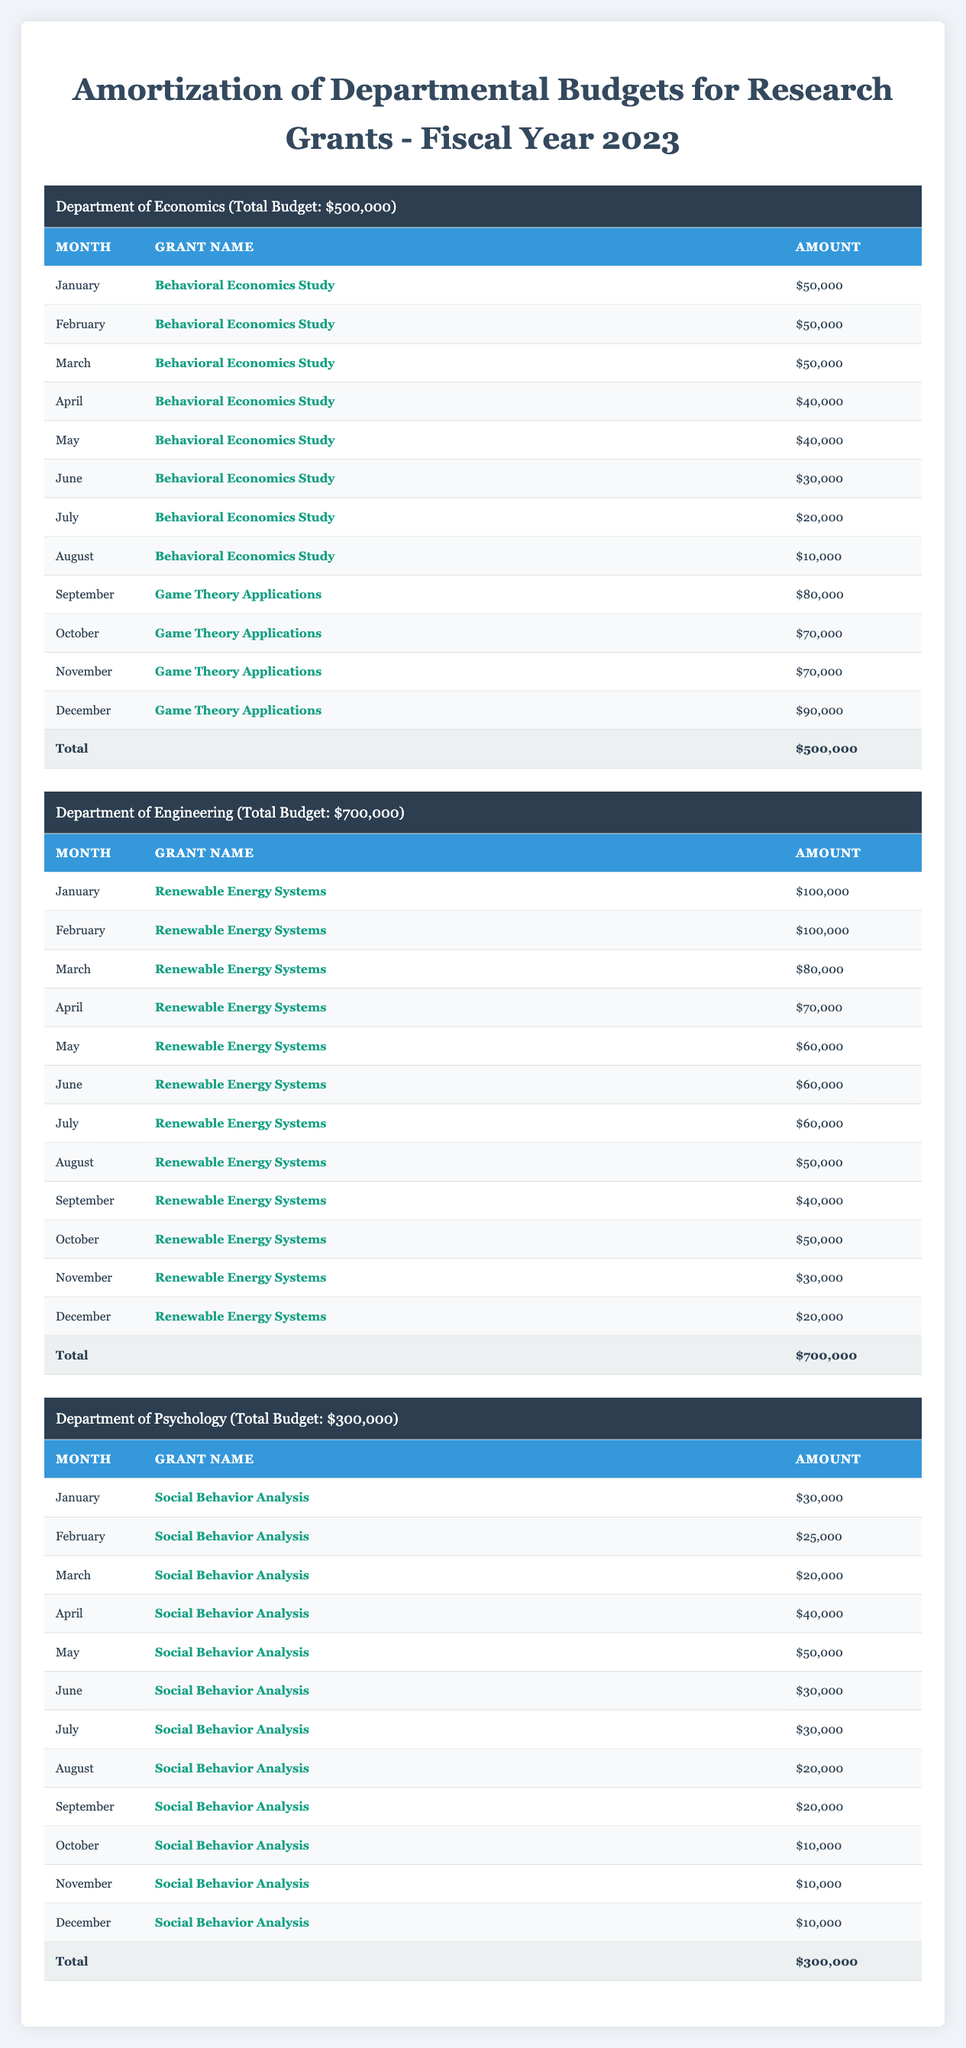What is the total budget for the Department of Psychology? The total budget for the Department of Psychology is explicitly stated in the table as $300,000.
Answer: $300,000 How much was allocated for the Behavioral Economics Study in June? In the disbursement schedule for the Behavioral Economics Study, the amount allocated for June is listed as $30,000.
Answer: $30,000 Which department has the highest monthly amortization amount? The Department of Engineering has the highest monthly amortization amount at $58,334, compared to $41,667 for the Department of Economics and $25,000 for the Department of Psychology.
Answer: Department of Engineering How much total funding was allocated to the Renewable Energy Systems grant from January to March? The table shows that in January, $100,000 was allocated, in February $100,000, and in March $80,000. Adding these amounts gives $100,000 + $100,000 + $80,000 = $280,000.
Answer: $280,000 Is the total amount disbursed for the Game Theory Applications grant higher than that of the Social Behavior Analysis grant? The total amount for Game Theory Applications is $320,000 (80,000 + 70,000 + 70,000 + 90,000) while Social Behavior Analysis totals $300,000 (30,000 + 25,000 + 20,000 + 40,000 + 50,000 + 30,000 + 30,000 + 20,000 + 20,000 + 10,000 + 10,000 + 10,000). Since 320,000 > 300,000, the statement is true.
Answer: Yes What is the average monthly amortization across all three departments? The monthly amortizations are $41,667 (Economics), $58,334 (Engineering), and $25,000 (Psychology). Summing these gives $41,667 + $58,334 + $25,000 = $125,001. Dividing by 3 (the number of departments) gives an average of $125,001 / 3 ≈ $41,667.
Answer: $41,667 How much was allocated to the Social Behavior Analysis grant in the last quarter (October to December)? For the Social Behavior Analysis grant, the amounts in the last quarter are: October $10,000, November $10,000, and December $10,000. Summing these gives $10,000 + $10,000 + $10,000 = $30,000.
Answer: $30,000 Which month had the highest disbursement for the Department of Engineering? Reviewing the amounts in the table, January has the highest disbursement of $100,000 for the Renewable Energy Systems grant, which is higher than any other month for that department.
Answer: January Was any amount disbursed in May for the Game Theory Applications grant? According to the disbursement schedule for Game Theory Applications, there was no amount allocated for May, making the statement true.
Answer: No 